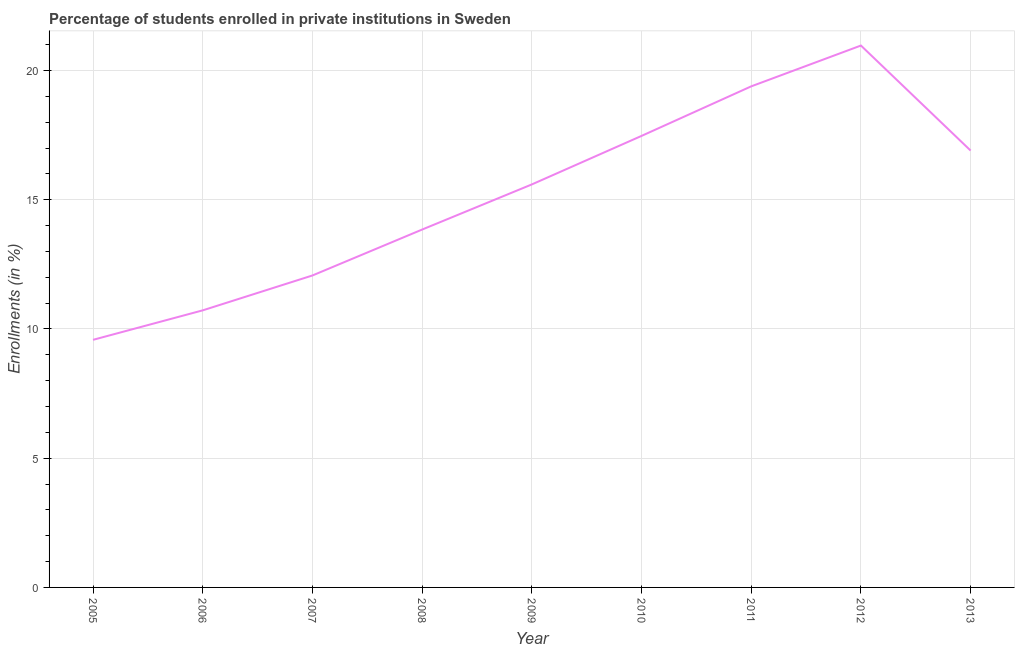What is the enrollments in private institutions in 2009?
Give a very brief answer. 15.59. Across all years, what is the maximum enrollments in private institutions?
Your answer should be compact. 20.97. Across all years, what is the minimum enrollments in private institutions?
Make the answer very short. 9.58. In which year was the enrollments in private institutions maximum?
Provide a succinct answer. 2012. What is the sum of the enrollments in private institutions?
Give a very brief answer. 136.54. What is the difference between the enrollments in private institutions in 2005 and 2012?
Your response must be concise. -11.39. What is the average enrollments in private institutions per year?
Offer a very short reply. 15.17. What is the median enrollments in private institutions?
Ensure brevity in your answer.  15.59. In how many years, is the enrollments in private institutions greater than 4 %?
Offer a terse response. 9. What is the ratio of the enrollments in private institutions in 2008 to that in 2013?
Your answer should be compact. 0.82. Is the enrollments in private institutions in 2006 less than that in 2008?
Provide a succinct answer. Yes. Is the difference between the enrollments in private institutions in 2005 and 2012 greater than the difference between any two years?
Ensure brevity in your answer.  Yes. What is the difference between the highest and the second highest enrollments in private institutions?
Keep it short and to the point. 1.58. What is the difference between the highest and the lowest enrollments in private institutions?
Give a very brief answer. 11.39. In how many years, is the enrollments in private institutions greater than the average enrollments in private institutions taken over all years?
Provide a succinct answer. 5. Does the enrollments in private institutions monotonically increase over the years?
Keep it short and to the point. No. How many lines are there?
Ensure brevity in your answer.  1. Does the graph contain any zero values?
Your answer should be very brief. No. What is the title of the graph?
Provide a succinct answer. Percentage of students enrolled in private institutions in Sweden. What is the label or title of the Y-axis?
Your response must be concise. Enrollments (in %). What is the Enrollments (in %) of 2005?
Your answer should be very brief. 9.58. What is the Enrollments (in %) in 2006?
Your response must be concise. 10.72. What is the Enrollments (in %) in 2007?
Offer a terse response. 12.07. What is the Enrollments (in %) in 2008?
Your answer should be compact. 13.85. What is the Enrollments (in %) of 2009?
Provide a succinct answer. 15.59. What is the Enrollments (in %) in 2010?
Offer a very short reply. 17.47. What is the Enrollments (in %) of 2011?
Offer a terse response. 19.39. What is the Enrollments (in %) in 2012?
Offer a terse response. 20.97. What is the Enrollments (in %) in 2013?
Offer a very short reply. 16.9. What is the difference between the Enrollments (in %) in 2005 and 2006?
Give a very brief answer. -1.14. What is the difference between the Enrollments (in %) in 2005 and 2007?
Ensure brevity in your answer.  -2.49. What is the difference between the Enrollments (in %) in 2005 and 2008?
Offer a very short reply. -4.27. What is the difference between the Enrollments (in %) in 2005 and 2009?
Your answer should be very brief. -6.01. What is the difference between the Enrollments (in %) in 2005 and 2010?
Provide a short and direct response. -7.89. What is the difference between the Enrollments (in %) in 2005 and 2011?
Provide a short and direct response. -9.81. What is the difference between the Enrollments (in %) in 2005 and 2012?
Your answer should be compact. -11.39. What is the difference between the Enrollments (in %) in 2005 and 2013?
Ensure brevity in your answer.  -7.32. What is the difference between the Enrollments (in %) in 2006 and 2007?
Offer a very short reply. -1.35. What is the difference between the Enrollments (in %) in 2006 and 2008?
Your answer should be very brief. -3.13. What is the difference between the Enrollments (in %) in 2006 and 2009?
Make the answer very short. -4.87. What is the difference between the Enrollments (in %) in 2006 and 2010?
Your answer should be very brief. -6.75. What is the difference between the Enrollments (in %) in 2006 and 2011?
Make the answer very short. -8.67. What is the difference between the Enrollments (in %) in 2006 and 2012?
Make the answer very short. -10.25. What is the difference between the Enrollments (in %) in 2006 and 2013?
Offer a very short reply. -6.18. What is the difference between the Enrollments (in %) in 2007 and 2008?
Provide a short and direct response. -1.78. What is the difference between the Enrollments (in %) in 2007 and 2009?
Offer a terse response. -3.52. What is the difference between the Enrollments (in %) in 2007 and 2010?
Provide a short and direct response. -5.4. What is the difference between the Enrollments (in %) in 2007 and 2011?
Ensure brevity in your answer.  -7.32. What is the difference between the Enrollments (in %) in 2007 and 2012?
Your response must be concise. -8.9. What is the difference between the Enrollments (in %) in 2007 and 2013?
Your answer should be compact. -4.83. What is the difference between the Enrollments (in %) in 2008 and 2009?
Offer a terse response. -1.75. What is the difference between the Enrollments (in %) in 2008 and 2010?
Your answer should be compact. -3.62. What is the difference between the Enrollments (in %) in 2008 and 2011?
Make the answer very short. -5.54. What is the difference between the Enrollments (in %) in 2008 and 2012?
Your answer should be compact. -7.12. What is the difference between the Enrollments (in %) in 2008 and 2013?
Provide a short and direct response. -3.06. What is the difference between the Enrollments (in %) in 2009 and 2010?
Provide a succinct answer. -1.88. What is the difference between the Enrollments (in %) in 2009 and 2011?
Provide a short and direct response. -3.79. What is the difference between the Enrollments (in %) in 2009 and 2012?
Offer a terse response. -5.37. What is the difference between the Enrollments (in %) in 2009 and 2013?
Offer a very short reply. -1.31. What is the difference between the Enrollments (in %) in 2010 and 2011?
Give a very brief answer. -1.92. What is the difference between the Enrollments (in %) in 2010 and 2012?
Provide a succinct answer. -3.5. What is the difference between the Enrollments (in %) in 2010 and 2013?
Provide a succinct answer. 0.57. What is the difference between the Enrollments (in %) in 2011 and 2012?
Keep it short and to the point. -1.58. What is the difference between the Enrollments (in %) in 2011 and 2013?
Your answer should be compact. 2.48. What is the difference between the Enrollments (in %) in 2012 and 2013?
Offer a very short reply. 4.06. What is the ratio of the Enrollments (in %) in 2005 to that in 2006?
Offer a very short reply. 0.89. What is the ratio of the Enrollments (in %) in 2005 to that in 2007?
Your response must be concise. 0.79. What is the ratio of the Enrollments (in %) in 2005 to that in 2008?
Keep it short and to the point. 0.69. What is the ratio of the Enrollments (in %) in 2005 to that in 2009?
Make the answer very short. 0.61. What is the ratio of the Enrollments (in %) in 2005 to that in 2010?
Give a very brief answer. 0.55. What is the ratio of the Enrollments (in %) in 2005 to that in 2011?
Make the answer very short. 0.49. What is the ratio of the Enrollments (in %) in 2005 to that in 2012?
Offer a terse response. 0.46. What is the ratio of the Enrollments (in %) in 2005 to that in 2013?
Your answer should be compact. 0.57. What is the ratio of the Enrollments (in %) in 2006 to that in 2007?
Give a very brief answer. 0.89. What is the ratio of the Enrollments (in %) in 2006 to that in 2008?
Offer a very short reply. 0.77. What is the ratio of the Enrollments (in %) in 2006 to that in 2009?
Provide a short and direct response. 0.69. What is the ratio of the Enrollments (in %) in 2006 to that in 2010?
Offer a terse response. 0.61. What is the ratio of the Enrollments (in %) in 2006 to that in 2011?
Offer a terse response. 0.55. What is the ratio of the Enrollments (in %) in 2006 to that in 2012?
Offer a terse response. 0.51. What is the ratio of the Enrollments (in %) in 2006 to that in 2013?
Your answer should be very brief. 0.63. What is the ratio of the Enrollments (in %) in 2007 to that in 2008?
Provide a short and direct response. 0.87. What is the ratio of the Enrollments (in %) in 2007 to that in 2009?
Keep it short and to the point. 0.77. What is the ratio of the Enrollments (in %) in 2007 to that in 2010?
Provide a short and direct response. 0.69. What is the ratio of the Enrollments (in %) in 2007 to that in 2011?
Offer a terse response. 0.62. What is the ratio of the Enrollments (in %) in 2007 to that in 2012?
Your answer should be very brief. 0.58. What is the ratio of the Enrollments (in %) in 2007 to that in 2013?
Offer a terse response. 0.71. What is the ratio of the Enrollments (in %) in 2008 to that in 2009?
Provide a succinct answer. 0.89. What is the ratio of the Enrollments (in %) in 2008 to that in 2010?
Ensure brevity in your answer.  0.79. What is the ratio of the Enrollments (in %) in 2008 to that in 2011?
Keep it short and to the point. 0.71. What is the ratio of the Enrollments (in %) in 2008 to that in 2012?
Keep it short and to the point. 0.66. What is the ratio of the Enrollments (in %) in 2008 to that in 2013?
Your answer should be compact. 0.82. What is the ratio of the Enrollments (in %) in 2009 to that in 2010?
Your answer should be very brief. 0.89. What is the ratio of the Enrollments (in %) in 2009 to that in 2011?
Your answer should be compact. 0.8. What is the ratio of the Enrollments (in %) in 2009 to that in 2012?
Your answer should be very brief. 0.74. What is the ratio of the Enrollments (in %) in 2009 to that in 2013?
Ensure brevity in your answer.  0.92. What is the ratio of the Enrollments (in %) in 2010 to that in 2011?
Provide a short and direct response. 0.9. What is the ratio of the Enrollments (in %) in 2010 to that in 2012?
Your answer should be compact. 0.83. What is the ratio of the Enrollments (in %) in 2010 to that in 2013?
Provide a short and direct response. 1.03. What is the ratio of the Enrollments (in %) in 2011 to that in 2012?
Provide a succinct answer. 0.93. What is the ratio of the Enrollments (in %) in 2011 to that in 2013?
Your response must be concise. 1.15. What is the ratio of the Enrollments (in %) in 2012 to that in 2013?
Your answer should be compact. 1.24. 